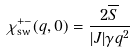Convert formula to latex. <formula><loc_0><loc_0><loc_500><loc_500>\chi _ { \text {sw} } ^ { + - } ( q , 0 ) = \frac { 2 \overline { S } } { | J | \gamma q ^ { 2 } }</formula> 